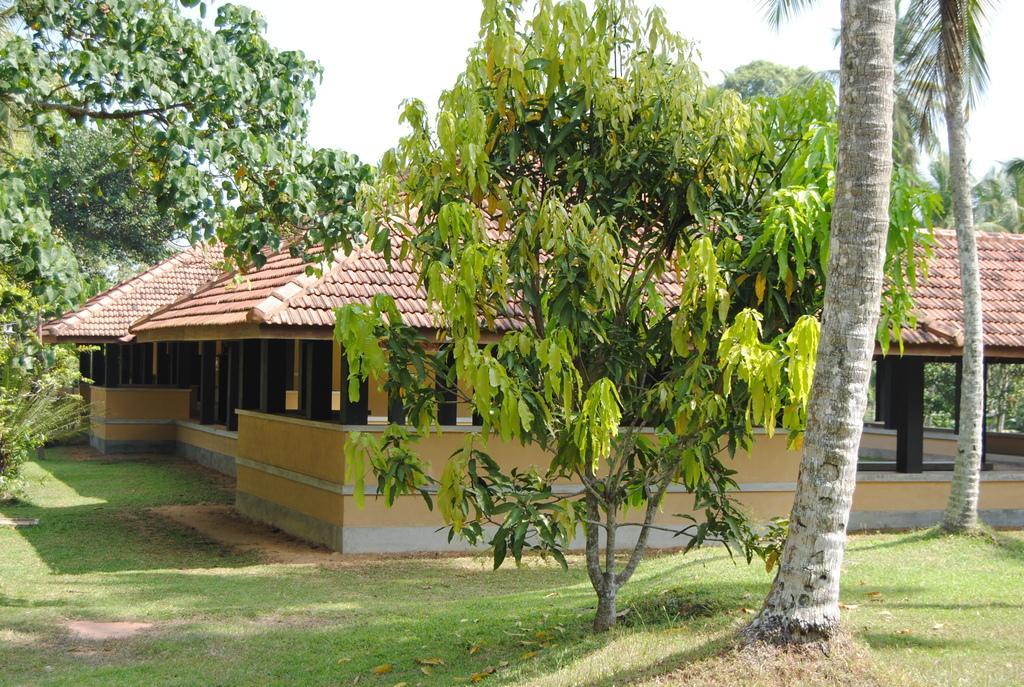Can you describe this image briefly? In this picture we can see a shed, trees, grass on the ground and we can see sky in the background. 